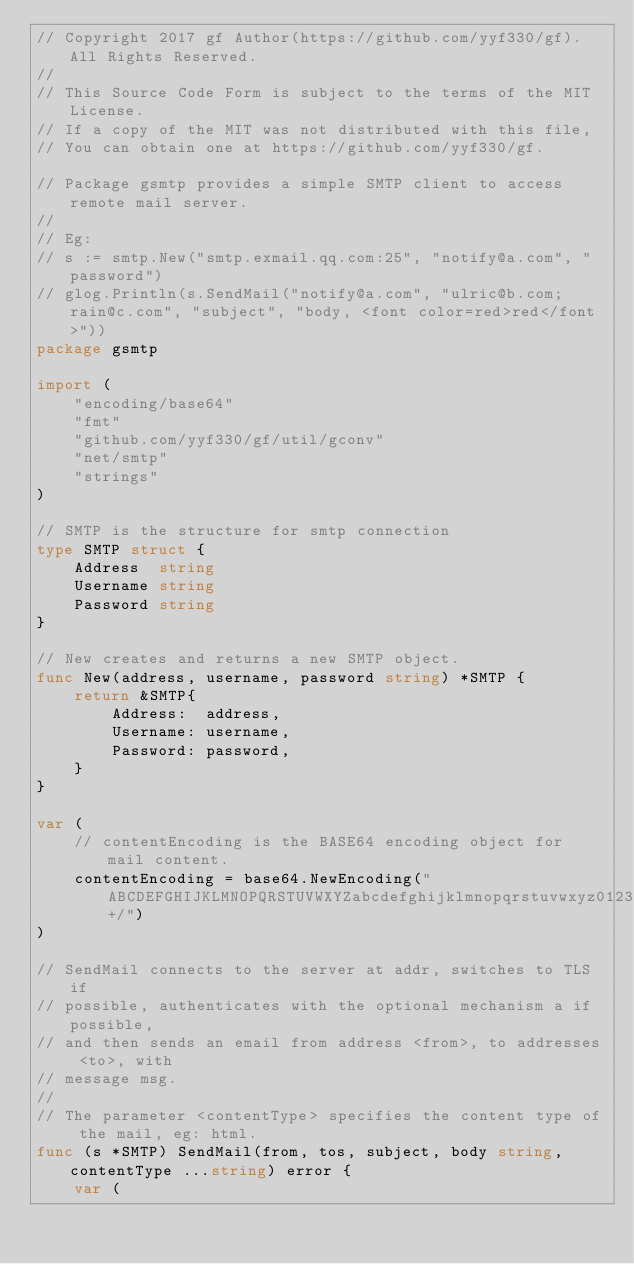<code> <loc_0><loc_0><loc_500><loc_500><_Go_>// Copyright 2017 gf Author(https://github.com/yyf330/gf). All Rights Reserved.
//
// This Source Code Form is subject to the terms of the MIT License.
// If a copy of the MIT was not distributed with this file,
// You can obtain one at https://github.com/yyf330/gf.

// Package gsmtp provides a simple SMTP client to access remote mail server.
//
// Eg:
// s := smtp.New("smtp.exmail.qq.com:25", "notify@a.com", "password")
// glog.Println(s.SendMail("notify@a.com", "ulric@b.com;rain@c.com", "subject", "body, <font color=red>red</font>"))
package gsmtp

import (
	"encoding/base64"
	"fmt"
	"github.com/yyf330/gf/util/gconv"
	"net/smtp"
	"strings"
)

// SMTP is the structure for smtp connection
type SMTP struct {
	Address  string
	Username string
	Password string
}

// New creates and returns a new SMTP object.
func New(address, username, password string) *SMTP {
	return &SMTP{
		Address:  address,
		Username: username,
		Password: password,
	}
}

var (
	// contentEncoding is the BASE64 encoding object for mail content.
	contentEncoding = base64.NewEncoding("ABCDEFGHIJKLMNOPQRSTUVWXYZabcdefghijklmnopqrstuvwxyz0123456789+/")
)

// SendMail connects to the server at addr, switches to TLS if
// possible, authenticates with the optional mechanism a if possible,
// and then sends an email from address <from>, to addresses <to>, with
// message msg.
//
// The parameter <contentType> specifies the content type of the mail, eg: html.
func (s *SMTP) SendMail(from, tos, subject, body string, contentType ...string) error {
	var (</code> 